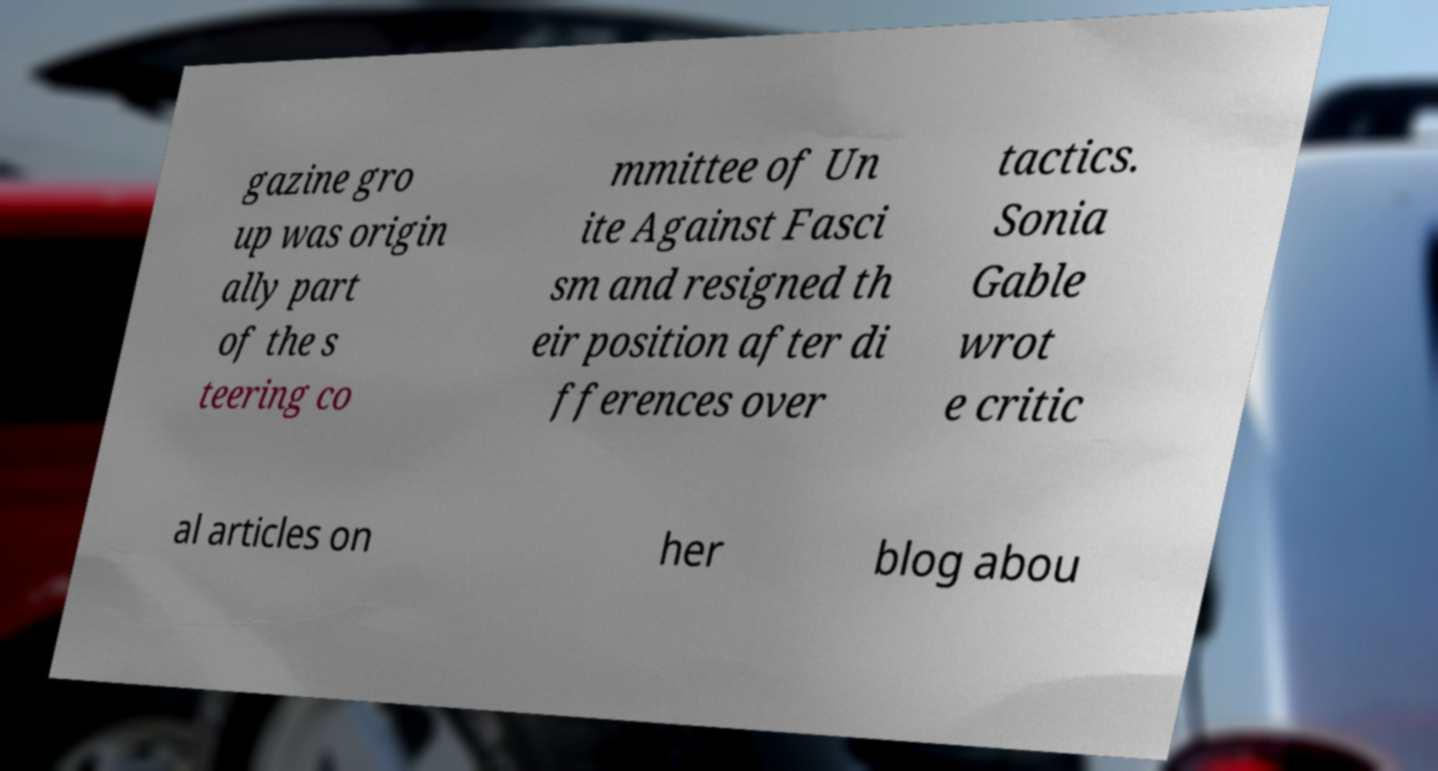Can you read and provide the text displayed in the image?This photo seems to have some interesting text. Can you extract and type it out for me? gazine gro up was origin ally part of the s teering co mmittee of Un ite Against Fasci sm and resigned th eir position after di fferences over tactics. Sonia Gable wrot e critic al articles on her blog abou 